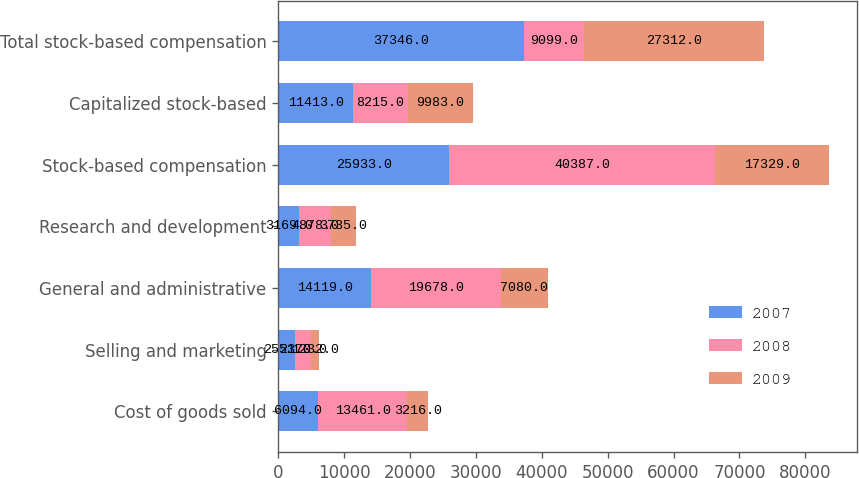Convert chart to OTSL. <chart><loc_0><loc_0><loc_500><loc_500><stacked_bar_chart><ecel><fcel>Cost of goods sold<fcel>Selling and marketing<fcel>General and administrative<fcel>Research and development<fcel>Stock-based compensation<fcel>Capitalized stock-based<fcel>Total stock-based compensation<nl><fcel>2007<fcel>6094<fcel>2551<fcel>14119<fcel>3169<fcel>25933<fcel>11413<fcel>37346<nl><fcel>2008<fcel>13461<fcel>2370<fcel>19678<fcel>4878<fcel>40387<fcel>8215<fcel>9099<nl><fcel>2009<fcel>3216<fcel>1232<fcel>7080<fcel>3735<fcel>17329<fcel>9983<fcel>27312<nl></chart> 